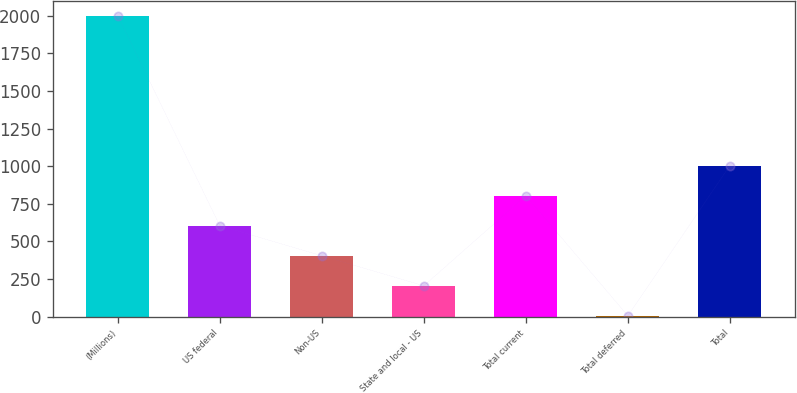Convert chart to OTSL. <chart><loc_0><loc_0><loc_500><loc_500><bar_chart><fcel>(Millions)<fcel>US federal<fcel>Non-US<fcel>State and local - US<fcel>Total current<fcel>Total deferred<fcel>Total<nl><fcel>2001<fcel>604.5<fcel>405<fcel>205.5<fcel>804<fcel>6<fcel>1003.5<nl></chart> 